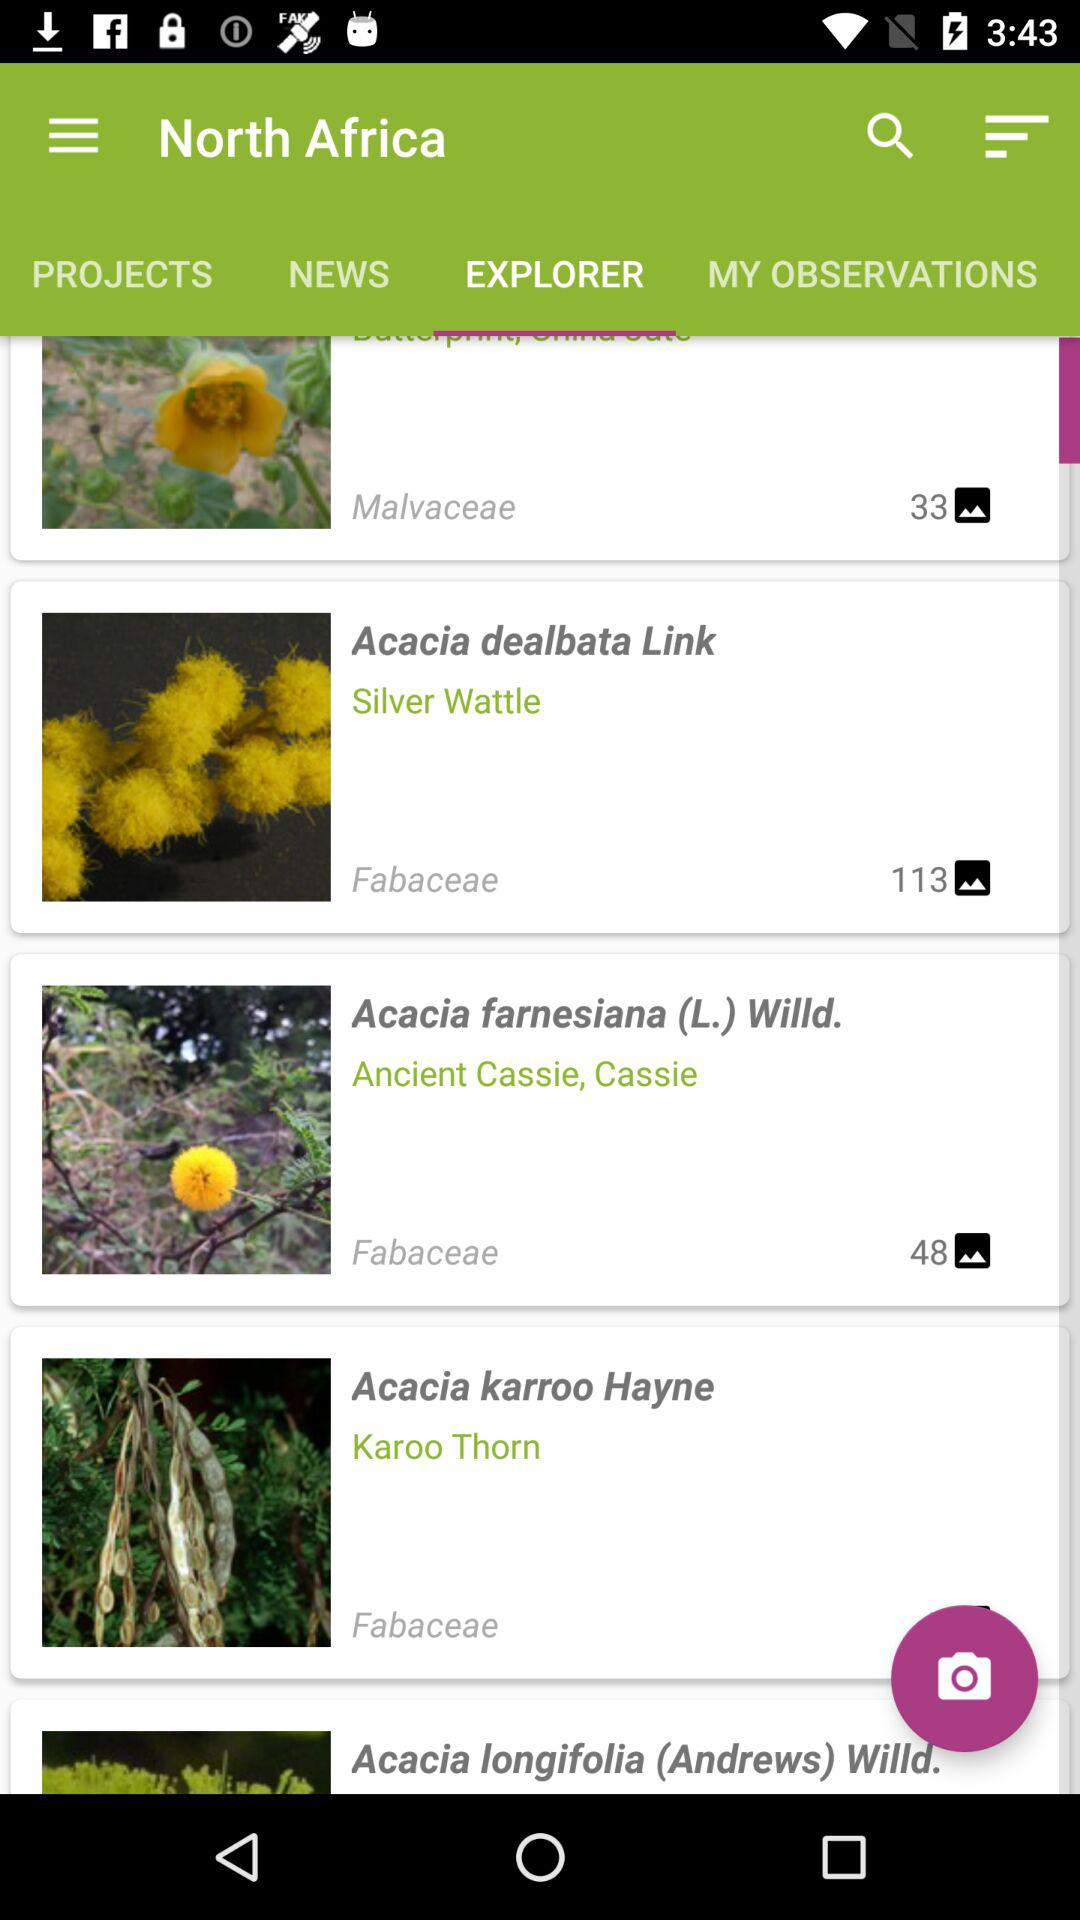Which tab is selected? The selected tab is "EXPLORER". 